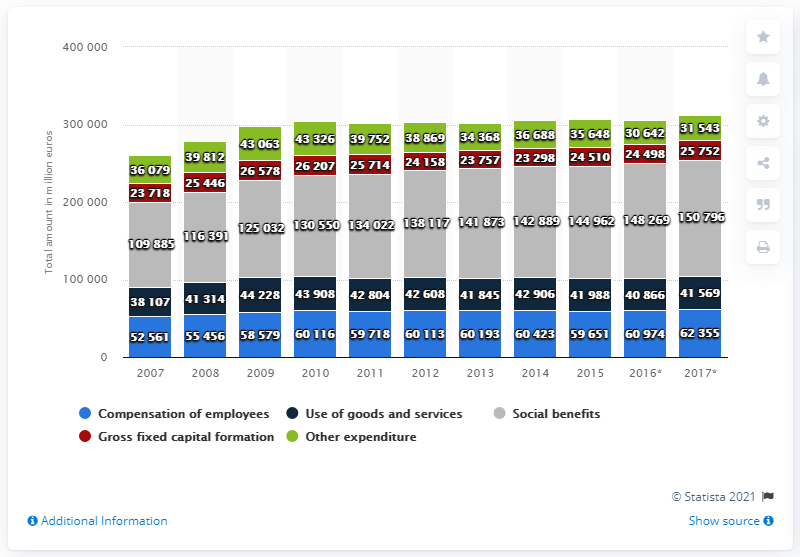Give some essential details in this illustration. In 2017, the Dutch government spent approximately 150,796 on social benefits. 